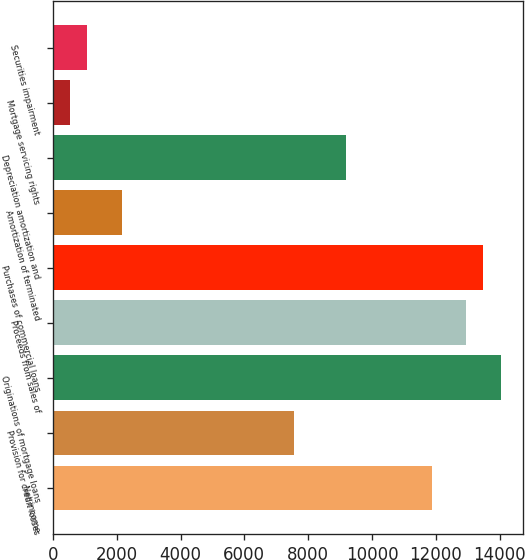<chart> <loc_0><loc_0><loc_500><loc_500><bar_chart><fcel>Net income<fcel>Provision for credit losses<fcel>Originations of mortgage loans<fcel>Proceeds from sales of<fcel>Purchases of commercial loans<fcel>Amortization of terminated<fcel>Depreciation amortization and<fcel>Mortgage servicing rights<fcel>Securities impairment<nl><fcel>11865.6<fcel>7551.2<fcel>14022.8<fcel>12944.2<fcel>13483.5<fcel>2158.2<fcel>9169.1<fcel>540.3<fcel>1079.6<nl></chart> 